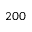Convert formula to latex. <formula><loc_0><loc_0><loc_500><loc_500>2 0 0</formula> 